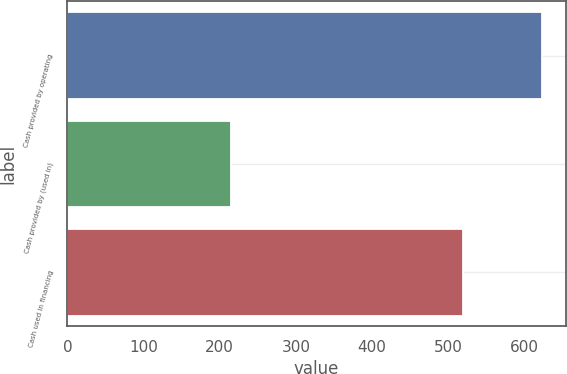<chart> <loc_0><loc_0><loc_500><loc_500><bar_chart><fcel>Cash provided by operating<fcel>Cash provided by (used in)<fcel>Cash used in financing<nl><fcel>623<fcel>215<fcel>519<nl></chart> 